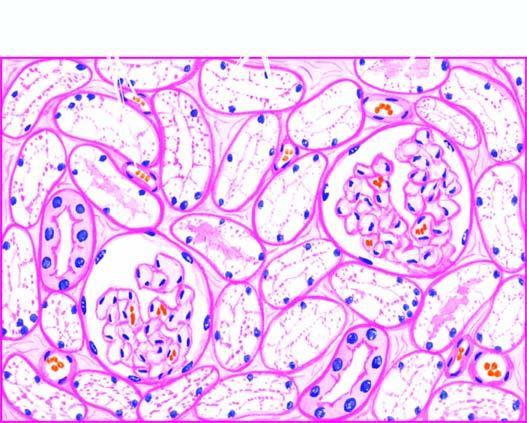s the interstitial vasculature compressed?
Answer the question using a single word or phrase. Yes 